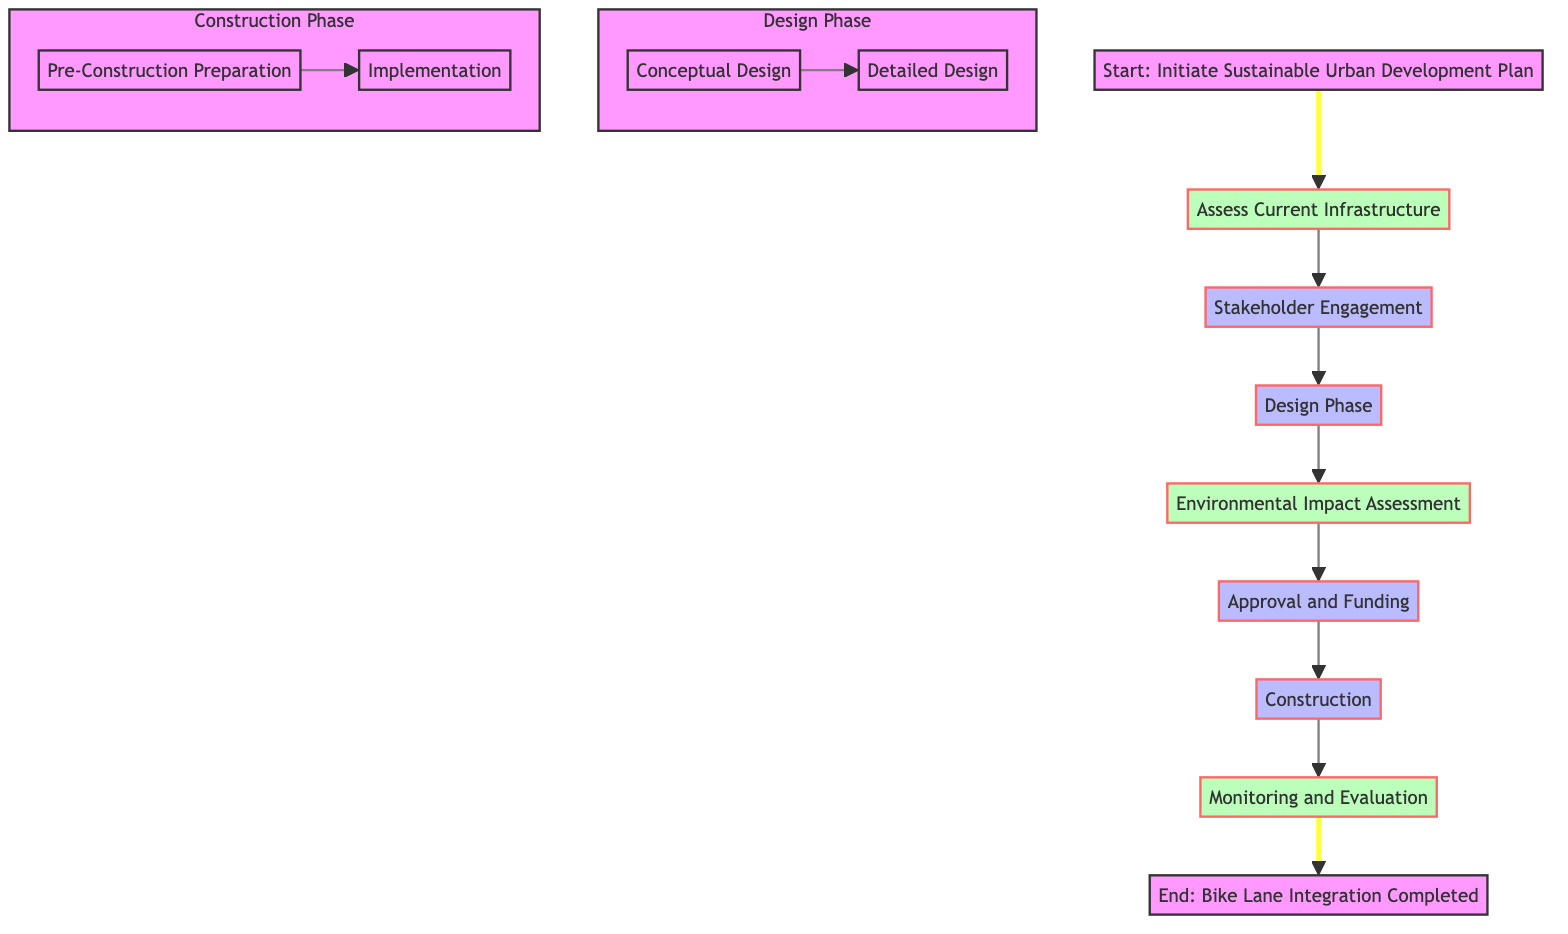What is the first step in the integration process? The first step according to the diagram is "Initiate Sustainable Urban Development Plan". This is identified as the starting point before any further actions take place.
Answer: Initiate Sustainable Urban Development Plan How many main phases are there in the diagram? The diagram has four main phases: Assessment, Stakeholder Engagement, Design Phase, and Construction Phase. These phases are clearly delineated in the flow and represent distinct steps in the integration process.
Answer: Four Which node follows the Environmental Impact Assessment? The node that follows Environmental Impact Assessment is Approval and Funding. This can be deduced by following the directed flow from the Environmental Impact Assessment node to the next node in the sequence.
Answer: Approval and Funding What tools are used during the Design Phase? The tools used during the Design Phase, specifically in the Conceptual Design and Detailed Design, are CAD Software and BIM Software, respectively. These tools are listed in the diagram under the specific design processes.
Answer: CAD Software, BIM Software What is the last step in the integration process? The last step in the integration process is "Bike Lane Integration Completed". This represents the conclusion of all previous steps and indicates the successful integration of bike lanes.
Answer: Bike Lane Integration Completed What is the relationship between the Assess Current Infrastructure and Stakeholder Engagement nodes? The relationship is sequential; Stakeholder Engagement follows Assess Current Infrastructure in the flow of the process. This implies that the assessment of infrastructure must occur before engaging stakeholders for input.
Answer: Sequential Which phase includes Collaborators from both Urban Planners and Traffic Engineers? The phase that includes Collaborators from both Urban Planners and Traffic Engineers is Assess Current Infrastructure. This collaborative effort is essential for evaluating existing road networks and traffic conditions.
Answer: Assess Current Infrastructure What tasks are involved in the Pre-Construction Preparation? The tasks involved in the Pre-Construction Preparation include Site Clearing, Material Procurement, and Contractor Selection. These tasks are crucial for setting up the construction phase effectively.
Answer: Site Clearing, Material Procurement, Contractor Selection Which method is used in Monitoring and Evaluation? The methods used in Monitoring and Evaluation are Usage Surveys, Condition Assessments, and Feedback Collection. This variety of methods ensures thorough monitoring of the bike lanes post-construction.
Answer: Usage Surveys, Condition Assessments, Feedback Collection 